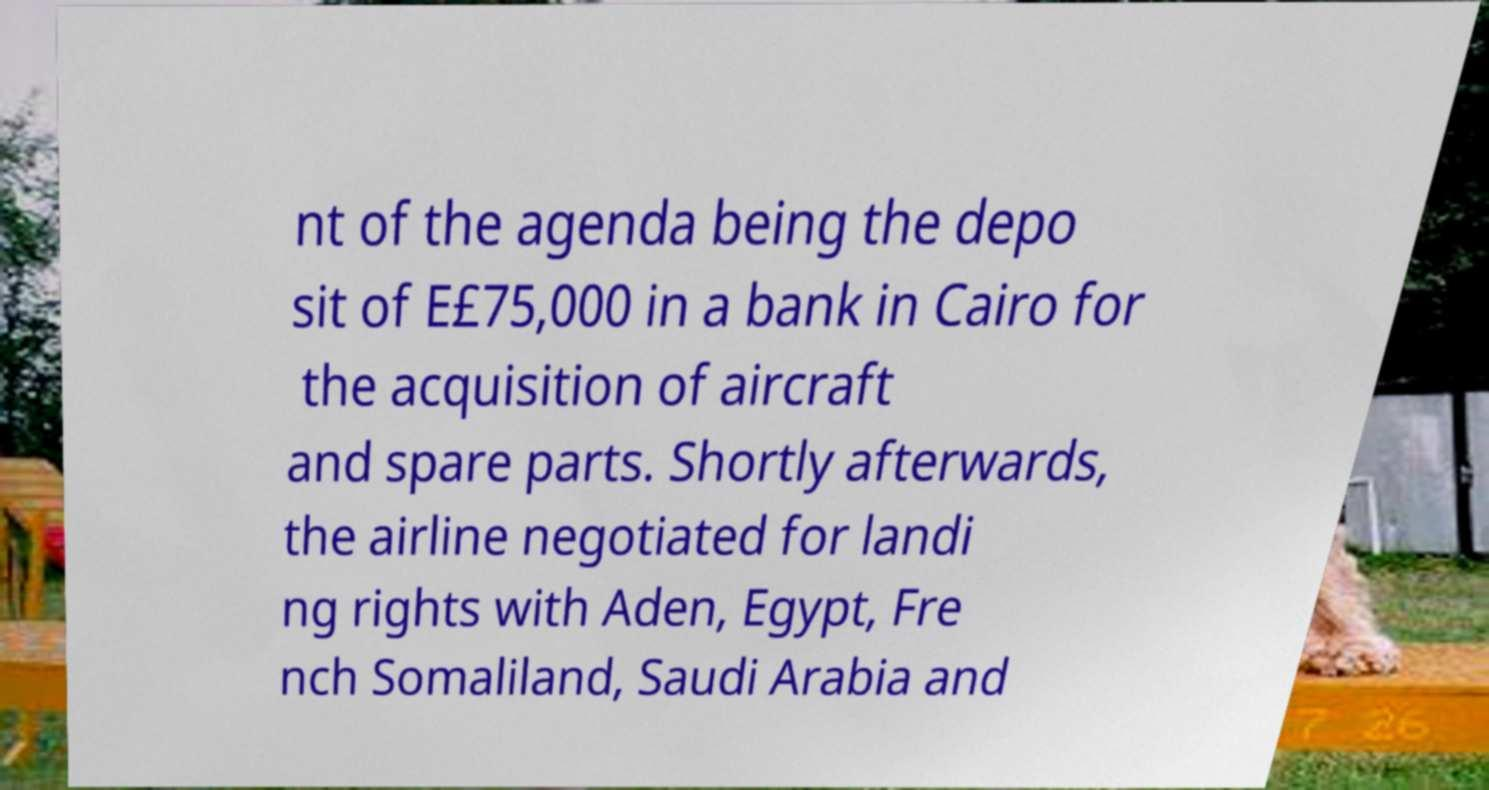Please read and relay the text visible in this image. What does it say? nt of the agenda being the depo sit of E£75,000 in a bank in Cairo for the acquisition of aircraft and spare parts. Shortly afterwards, the airline negotiated for landi ng rights with Aden, Egypt, Fre nch Somaliland, Saudi Arabia and 